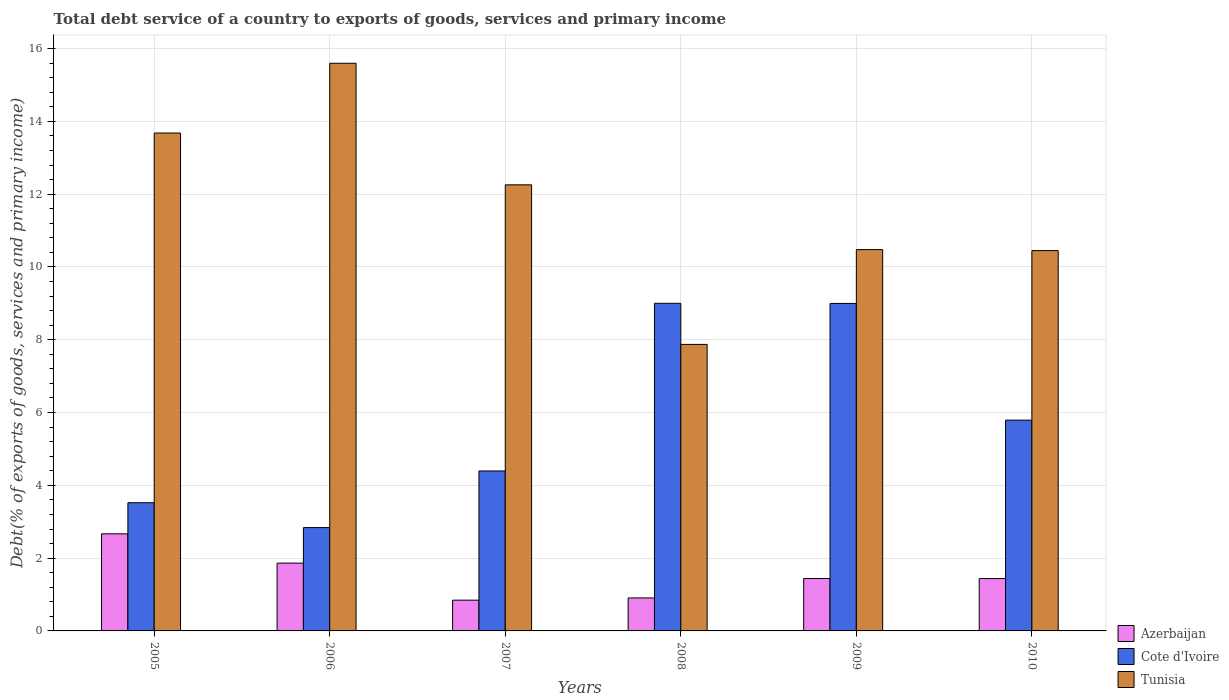How many different coloured bars are there?
Your answer should be compact. 3. Are the number of bars per tick equal to the number of legend labels?
Make the answer very short. Yes. How many bars are there on the 5th tick from the left?
Provide a succinct answer. 3. How many bars are there on the 2nd tick from the right?
Make the answer very short. 3. In how many cases, is the number of bars for a given year not equal to the number of legend labels?
Your answer should be very brief. 0. What is the total debt service in Azerbaijan in 2009?
Keep it short and to the point. 1.44. Across all years, what is the maximum total debt service in Azerbaijan?
Keep it short and to the point. 2.67. Across all years, what is the minimum total debt service in Cote d'Ivoire?
Offer a terse response. 2.84. In which year was the total debt service in Tunisia maximum?
Offer a very short reply. 2006. In which year was the total debt service in Azerbaijan minimum?
Your answer should be very brief. 2007. What is the total total debt service in Tunisia in the graph?
Provide a succinct answer. 70.33. What is the difference between the total debt service in Cote d'Ivoire in 2006 and that in 2009?
Provide a succinct answer. -6.16. What is the difference between the total debt service in Azerbaijan in 2005 and the total debt service in Tunisia in 2006?
Offer a terse response. -12.93. What is the average total debt service in Tunisia per year?
Your response must be concise. 11.72. In the year 2006, what is the difference between the total debt service in Azerbaijan and total debt service in Cote d'Ivoire?
Ensure brevity in your answer.  -0.98. What is the ratio of the total debt service in Azerbaijan in 2006 to that in 2008?
Provide a short and direct response. 2.06. Is the difference between the total debt service in Azerbaijan in 2006 and 2009 greater than the difference between the total debt service in Cote d'Ivoire in 2006 and 2009?
Your answer should be compact. Yes. What is the difference between the highest and the second highest total debt service in Azerbaijan?
Your answer should be very brief. 0.8. What is the difference between the highest and the lowest total debt service in Tunisia?
Ensure brevity in your answer.  7.72. Is the sum of the total debt service in Azerbaijan in 2005 and 2010 greater than the maximum total debt service in Tunisia across all years?
Provide a short and direct response. No. What does the 1st bar from the left in 2005 represents?
Make the answer very short. Azerbaijan. What does the 3rd bar from the right in 2008 represents?
Provide a succinct answer. Azerbaijan. How many bars are there?
Provide a succinct answer. 18. What is the difference between two consecutive major ticks on the Y-axis?
Give a very brief answer. 2. Does the graph contain grids?
Ensure brevity in your answer.  Yes. Where does the legend appear in the graph?
Keep it short and to the point. Bottom right. How many legend labels are there?
Offer a very short reply. 3. What is the title of the graph?
Offer a terse response. Total debt service of a country to exports of goods, services and primary income. Does "Bolivia" appear as one of the legend labels in the graph?
Offer a very short reply. No. What is the label or title of the Y-axis?
Make the answer very short. Debt(% of exports of goods, services and primary income). What is the Debt(% of exports of goods, services and primary income) of Azerbaijan in 2005?
Offer a terse response. 2.67. What is the Debt(% of exports of goods, services and primary income) in Cote d'Ivoire in 2005?
Ensure brevity in your answer.  3.52. What is the Debt(% of exports of goods, services and primary income) in Tunisia in 2005?
Your answer should be very brief. 13.68. What is the Debt(% of exports of goods, services and primary income) in Azerbaijan in 2006?
Your response must be concise. 1.86. What is the Debt(% of exports of goods, services and primary income) in Cote d'Ivoire in 2006?
Provide a succinct answer. 2.84. What is the Debt(% of exports of goods, services and primary income) of Tunisia in 2006?
Make the answer very short. 15.6. What is the Debt(% of exports of goods, services and primary income) in Azerbaijan in 2007?
Make the answer very short. 0.85. What is the Debt(% of exports of goods, services and primary income) in Cote d'Ivoire in 2007?
Provide a short and direct response. 4.39. What is the Debt(% of exports of goods, services and primary income) of Tunisia in 2007?
Ensure brevity in your answer.  12.26. What is the Debt(% of exports of goods, services and primary income) in Azerbaijan in 2008?
Give a very brief answer. 0.91. What is the Debt(% of exports of goods, services and primary income) in Cote d'Ivoire in 2008?
Provide a short and direct response. 9. What is the Debt(% of exports of goods, services and primary income) of Tunisia in 2008?
Your answer should be compact. 7.87. What is the Debt(% of exports of goods, services and primary income) of Azerbaijan in 2009?
Your response must be concise. 1.44. What is the Debt(% of exports of goods, services and primary income) of Cote d'Ivoire in 2009?
Give a very brief answer. 9. What is the Debt(% of exports of goods, services and primary income) in Tunisia in 2009?
Give a very brief answer. 10.48. What is the Debt(% of exports of goods, services and primary income) of Azerbaijan in 2010?
Offer a very short reply. 1.44. What is the Debt(% of exports of goods, services and primary income) of Cote d'Ivoire in 2010?
Provide a succinct answer. 5.79. What is the Debt(% of exports of goods, services and primary income) in Tunisia in 2010?
Offer a very short reply. 10.45. Across all years, what is the maximum Debt(% of exports of goods, services and primary income) in Azerbaijan?
Keep it short and to the point. 2.67. Across all years, what is the maximum Debt(% of exports of goods, services and primary income) in Cote d'Ivoire?
Keep it short and to the point. 9. Across all years, what is the maximum Debt(% of exports of goods, services and primary income) in Tunisia?
Offer a terse response. 15.6. Across all years, what is the minimum Debt(% of exports of goods, services and primary income) of Azerbaijan?
Make the answer very short. 0.85. Across all years, what is the minimum Debt(% of exports of goods, services and primary income) in Cote d'Ivoire?
Offer a terse response. 2.84. Across all years, what is the minimum Debt(% of exports of goods, services and primary income) in Tunisia?
Provide a short and direct response. 7.87. What is the total Debt(% of exports of goods, services and primary income) of Azerbaijan in the graph?
Offer a very short reply. 9.16. What is the total Debt(% of exports of goods, services and primary income) in Cote d'Ivoire in the graph?
Keep it short and to the point. 34.55. What is the total Debt(% of exports of goods, services and primary income) of Tunisia in the graph?
Offer a terse response. 70.33. What is the difference between the Debt(% of exports of goods, services and primary income) in Azerbaijan in 2005 and that in 2006?
Ensure brevity in your answer.  0.8. What is the difference between the Debt(% of exports of goods, services and primary income) of Cote d'Ivoire in 2005 and that in 2006?
Provide a succinct answer. 0.68. What is the difference between the Debt(% of exports of goods, services and primary income) in Tunisia in 2005 and that in 2006?
Provide a succinct answer. -1.92. What is the difference between the Debt(% of exports of goods, services and primary income) of Azerbaijan in 2005 and that in 2007?
Make the answer very short. 1.82. What is the difference between the Debt(% of exports of goods, services and primary income) in Cote d'Ivoire in 2005 and that in 2007?
Ensure brevity in your answer.  -0.87. What is the difference between the Debt(% of exports of goods, services and primary income) in Tunisia in 2005 and that in 2007?
Your answer should be compact. 1.42. What is the difference between the Debt(% of exports of goods, services and primary income) of Azerbaijan in 2005 and that in 2008?
Provide a succinct answer. 1.76. What is the difference between the Debt(% of exports of goods, services and primary income) of Cote d'Ivoire in 2005 and that in 2008?
Your answer should be very brief. -5.48. What is the difference between the Debt(% of exports of goods, services and primary income) of Tunisia in 2005 and that in 2008?
Your response must be concise. 5.81. What is the difference between the Debt(% of exports of goods, services and primary income) in Azerbaijan in 2005 and that in 2009?
Offer a terse response. 1.23. What is the difference between the Debt(% of exports of goods, services and primary income) of Cote d'Ivoire in 2005 and that in 2009?
Offer a very short reply. -5.47. What is the difference between the Debt(% of exports of goods, services and primary income) of Tunisia in 2005 and that in 2009?
Your answer should be very brief. 3.2. What is the difference between the Debt(% of exports of goods, services and primary income) in Azerbaijan in 2005 and that in 2010?
Make the answer very short. 1.23. What is the difference between the Debt(% of exports of goods, services and primary income) in Cote d'Ivoire in 2005 and that in 2010?
Your response must be concise. -2.27. What is the difference between the Debt(% of exports of goods, services and primary income) of Tunisia in 2005 and that in 2010?
Provide a succinct answer. 3.23. What is the difference between the Debt(% of exports of goods, services and primary income) in Azerbaijan in 2006 and that in 2007?
Provide a succinct answer. 1.02. What is the difference between the Debt(% of exports of goods, services and primary income) of Cote d'Ivoire in 2006 and that in 2007?
Make the answer very short. -1.56. What is the difference between the Debt(% of exports of goods, services and primary income) of Tunisia in 2006 and that in 2007?
Offer a terse response. 3.34. What is the difference between the Debt(% of exports of goods, services and primary income) in Azerbaijan in 2006 and that in 2008?
Provide a succinct answer. 0.96. What is the difference between the Debt(% of exports of goods, services and primary income) of Cote d'Ivoire in 2006 and that in 2008?
Offer a terse response. -6.16. What is the difference between the Debt(% of exports of goods, services and primary income) of Tunisia in 2006 and that in 2008?
Offer a terse response. 7.72. What is the difference between the Debt(% of exports of goods, services and primary income) in Azerbaijan in 2006 and that in 2009?
Your response must be concise. 0.42. What is the difference between the Debt(% of exports of goods, services and primary income) in Cote d'Ivoire in 2006 and that in 2009?
Ensure brevity in your answer.  -6.16. What is the difference between the Debt(% of exports of goods, services and primary income) in Tunisia in 2006 and that in 2009?
Your response must be concise. 5.12. What is the difference between the Debt(% of exports of goods, services and primary income) of Azerbaijan in 2006 and that in 2010?
Your response must be concise. 0.42. What is the difference between the Debt(% of exports of goods, services and primary income) of Cote d'Ivoire in 2006 and that in 2010?
Give a very brief answer. -2.95. What is the difference between the Debt(% of exports of goods, services and primary income) of Tunisia in 2006 and that in 2010?
Provide a short and direct response. 5.15. What is the difference between the Debt(% of exports of goods, services and primary income) in Azerbaijan in 2007 and that in 2008?
Provide a short and direct response. -0.06. What is the difference between the Debt(% of exports of goods, services and primary income) in Cote d'Ivoire in 2007 and that in 2008?
Give a very brief answer. -4.61. What is the difference between the Debt(% of exports of goods, services and primary income) of Tunisia in 2007 and that in 2008?
Provide a succinct answer. 4.38. What is the difference between the Debt(% of exports of goods, services and primary income) of Azerbaijan in 2007 and that in 2009?
Give a very brief answer. -0.59. What is the difference between the Debt(% of exports of goods, services and primary income) in Cote d'Ivoire in 2007 and that in 2009?
Your response must be concise. -4.6. What is the difference between the Debt(% of exports of goods, services and primary income) of Tunisia in 2007 and that in 2009?
Keep it short and to the point. 1.78. What is the difference between the Debt(% of exports of goods, services and primary income) in Azerbaijan in 2007 and that in 2010?
Make the answer very short. -0.59. What is the difference between the Debt(% of exports of goods, services and primary income) in Cote d'Ivoire in 2007 and that in 2010?
Offer a very short reply. -1.4. What is the difference between the Debt(% of exports of goods, services and primary income) in Tunisia in 2007 and that in 2010?
Your response must be concise. 1.81. What is the difference between the Debt(% of exports of goods, services and primary income) of Azerbaijan in 2008 and that in 2009?
Make the answer very short. -0.53. What is the difference between the Debt(% of exports of goods, services and primary income) in Cote d'Ivoire in 2008 and that in 2009?
Offer a terse response. 0. What is the difference between the Debt(% of exports of goods, services and primary income) of Tunisia in 2008 and that in 2009?
Make the answer very short. -2.6. What is the difference between the Debt(% of exports of goods, services and primary income) in Azerbaijan in 2008 and that in 2010?
Offer a terse response. -0.53. What is the difference between the Debt(% of exports of goods, services and primary income) in Cote d'Ivoire in 2008 and that in 2010?
Ensure brevity in your answer.  3.21. What is the difference between the Debt(% of exports of goods, services and primary income) in Tunisia in 2008 and that in 2010?
Provide a succinct answer. -2.58. What is the difference between the Debt(% of exports of goods, services and primary income) in Azerbaijan in 2009 and that in 2010?
Make the answer very short. 0. What is the difference between the Debt(% of exports of goods, services and primary income) of Cote d'Ivoire in 2009 and that in 2010?
Keep it short and to the point. 3.21. What is the difference between the Debt(% of exports of goods, services and primary income) in Tunisia in 2009 and that in 2010?
Provide a short and direct response. 0.03. What is the difference between the Debt(% of exports of goods, services and primary income) of Azerbaijan in 2005 and the Debt(% of exports of goods, services and primary income) of Cote d'Ivoire in 2006?
Provide a short and direct response. -0.17. What is the difference between the Debt(% of exports of goods, services and primary income) in Azerbaijan in 2005 and the Debt(% of exports of goods, services and primary income) in Tunisia in 2006?
Give a very brief answer. -12.93. What is the difference between the Debt(% of exports of goods, services and primary income) in Cote d'Ivoire in 2005 and the Debt(% of exports of goods, services and primary income) in Tunisia in 2006?
Offer a terse response. -12.07. What is the difference between the Debt(% of exports of goods, services and primary income) of Azerbaijan in 2005 and the Debt(% of exports of goods, services and primary income) of Cote d'Ivoire in 2007?
Offer a terse response. -1.73. What is the difference between the Debt(% of exports of goods, services and primary income) of Azerbaijan in 2005 and the Debt(% of exports of goods, services and primary income) of Tunisia in 2007?
Keep it short and to the point. -9.59. What is the difference between the Debt(% of exports of goods, services and primary income) in Cote d'Ivoire in 2005 and the Debt(% of exports of goods, services and primary income) in Tunisia in 2007?
Your answer should be very brief. -8.73. What is the difference between the Debt(% of exports of goods, services and primary income) in Azerbaijan in 2005 and the Debt(% of exports of goods, services and primary income) in Cote d'Ivoire in 2008?
Offer a terse response. -6.33. What is the difference between the Debt(% of exports of goods, services and primary income) of Azerbaijan in 2005 and the Debt(% of exports of goods, services and primary income) of Tunisia in 2008?
Offer a terse response. -5.21. What is the difference between the Debt(% of exports of goods, services and primary income) in Cote d'Ivoire in 2005 and the Debt(% of exports of goods, services and primary income) in Tunisia in 2008?
Give a very brief answer. -4.35. What is the difference between the Debt(% of exports of goods, services and primary income) in Azerbaijan in 2005 and the Debt(% of exports of goods, services and primary income) in Cote d'Ivoire in 2009?
Offer a very short reply. -6.33. What is the difference between the Debt(% of exports of goods, services and primary income) in Azerbaijan in 2005 and the Debt(% of exports of goods, services and primary income) in Tunisia in 2009?
Your response must be concise. -7.81. What is the difference between the Debt(% of exports of goods, services and primary income) of Cote d'Ivoire in 2005 and the Debt(% of exports of goods, services and primary income) of Tunisia in 2009?
Provide a short and direct response. -6.95. What is the difference between the Debt(% of exports of goods, services and primary income) of Azerbaijan in 2005 and the Debt(% of exports of goods, services and primary income) of Cote d'Ivoire in 2010?
Give a very brief answer. -3.12. What is the difference between the Debt(% of exports of goods, services and primary income) in Azerbaijan in 2005 and the Debt(% of exports of goods, services and primary income) in Tunisia in 2010?
Provide a succinct answer. -7.78. What is the difference between the Debt(% of exports of goods, services and primary income) of Cote d'Ivoire in 2005 and the Debt(% of exports of goods, services and primary income) of Tunisia in 2010?
Your answer should be compact. -6.93. What is the difference between the Debt(% of exports of goods, services and primary income) in Azerbaijan in 2006 and the Debt(% of exports of goods, services and primary income) in Cote d'Ivoire in 2007?
Your answer should be very brief. -2.53. What is the difference between the Debt(% of exports of goods, services and primary income) in Azerbaijan in 2006 and the Debt(% of exports of goods, services and primary income) in Tunisia in 2007?
Offer a terse response. -10.39. What is the difference between the Debt(% of exports of goods, services and primary income) in Cote d'Ivoire in 2006 and the Debt(% of exports of goods, services and primary income) in Tunisia in 2007?
Provide a succinct answer. -9.42. What is the difference between the Debt(% of exports of goods, services and primary income) in Azerbaijan in 2006 and the Debt(% of exports of goods, services and primary income) in Cote d'Ivoire in 2008?
Your answer should be very brief. -7.14. What is the difference between the Debt(% of exports of goods, services and primary income) in Azerbaijan in 2006 and the Debt(% of exports of goods, services and primary income) in Tunisia in 2008?
Offer a very short reply. -6.01. What is the difference between the Debt(% of exports of goods, services and primary income) of Cote d'Ivoire in 2006 and the Debt(% of exports of goods, services and primary income) of Tunisia in 2008?
Ensure brevity in your answer.  -5.03. What is the difference between the Debt(% of exports of goods, services and primary income) in Azerbaijan in 2006 and the Debt(% of exports of goods, services and primary income) in Cote d'Ivoire in 2009?
Your response must be concise. -7.13. What is the difference between the Debt(% of exports of goods, services and primary income) in Azerbaijan in 2006 and the Debt(% of exports of goods, services and primary income) in Tunisia in 2009?
Offer a terse response. -8.61. What is the difference between the Debt(% of exports of goods, services and primary income) of Cote d'Ivoire in 2006 and the Debt(% of exports of goods, services and primary income) of Tunisia in 2009?
Keep it short and to the point. -7.64. What is the difference between the Debt(% of exports of goods, services and primary income) of Azerbaijan in 2006 and the Debt(% of exports of goods, services and primary income) of Cote d'Ivoire in 2010?
Provide a succinct answer. -3.93. What is the difference between the Debt(% of exports of goods, services and primary income) of Azerbaijan in 2006 and the Debt(% of exports of goods, services and primary income) of Tunisia in 2010?
Make the answer very short. -8.59. What is the difference between the Debt(% of exports of goods, services and primary income) of Cote d'Ivoire in 2006 and the Debt(% of exports of goods, services and primary income) of Tunisia in 2010?
Your answer should be compact. -7.61. What is the difference between the Debt(% of exports of goods, services and primary income) of Azerbaijan in 2007 and the Debt(% of exports of goods, services and primary income) of Cote d'Ivoire in 2008?
Your answer should be very brief. -8.16. What is the difference between the Debt(% of exports of goods, services and primary income) of Azerbaijan in 2007 and the Debt(% of exports of goods, services and primary income) of Tunisia in 2008?
Your answer should be very brief. -7.03. What is the difference between the Debt(% of exports of goods, services and primary income) of Cote d'Ivoire in 2007 and the Debt(% of exports of goods, services and primary income) of Tunisia in 2008?
Offer a very short reply. -3.48. What is the difference between the Debt(% of exports of goods, services and primary income) in Azerbaijan in 2007 and the Debt(% of exports of goods, services and primary income) in Cote d'Ivoire in 2009?
Provide a succinct answer. -8.15. What is the difference between the Debt(% of exports of goods, services and primary income) of Azerbaijan in 2007 and the Debt(% of exports of goods, services and primary income) of Tunisia in 2009?
Your answer should be compact. -9.63. What is the difference between the Debt(% of exports of goods, services and primary income) in Cote d'Ivoire in 2007 and the Debt(% of exports of goods, services and primary income) in Tunisia in 2009?
Your answer should be very brief. -6.08. What is the difference between the Debt(% of exports of goods, services and primary income) of Azerbaijan in 2007 and the Debt(% of exports of goods, services and primary income) of Cote d'Ivoire in 2010?
Your answer should be very brief. -4.95. What is the difference between the Debt(% of exports of goods, services and primary income) in Azerbaijan in 2007 and the Debt(% of exports of goods, services and primary income) in Tunisia in 2010?
Provide a succinct answer. -9.6. What is the difference between the Debt(% of exports of goods, services and primary income) in Cote d'Ivoire in 2007 and the Debt(% of exports of goods, services and primary income) in Tunisia in 2010?
Keep it short and to the point. -6.05. What is the difference between the Debt(% of exports of goods, services and primary income) of Azerbaijan in 2008 and the Debt(% of exports of goods, services and primary income) of Cote d'Ivoire in 2009?
Provide a short and direct response. -8.09. What is the difference between the Debt(% of exports of goods, services and primary income) of Azerbaijan in 2008 and the Debt(% of exports of goods, services and primary income) of Tunisia in 2009?
Offer a very short reply. -9.57. What is the difference between the Debt(% of exports of goods, services and primary income) in Cote d'Ivoire in 2008 and the Debt(% of exports of goods, services and primary income) in Tunisia in 2009?
Your answer should be very brief. -1.48. What is the difference between the Debt(% of exports of goods, services and primary income) in Azerbaijan in 2008 and the Debt(% of exports of goods, services and primary income) in Cote d'Ivoire in 2010?
Ensure brevity in your answer.  -4.89. What is the difference between the Debt(% of exports of goods, services and primary income) of Azerbaijan in 2008 and the Debt(% of exports of goods, services and primary income) of Tunisia in 2010?
Your response must be concise. -9.54. What is the difference between the Debt(% of exports of goods, services and primary income) in Cote d'Ivoire in 2008 and the Debt(% of exports of goods, services and primary income) in Tunisia in 2010?
Your response must be concise. -1.45. What is the difference between the Debt(% of exports of goods, services and primary income) of Azerbaijan in 2009 and the Debt(% of exports of goods, services and primary income) of Cote d'Ivoire in 2010?
Your answer should be compact. -4.35. What is the difference between the Debt(% of exports of goods, services and primary income) of Azerbaijan in 2009 and the Debt(% of exports of goods, services and primary income) of Tunisia in 2010?
Your answer should be very brief. -9.01. What is the difference between the Debt(% of exports of goods, services and primary income) of Cote d'Ivoire in 2009 and the Debt(% of exports of goods, services and primary income) of Tunisia in 2010?
Provide a succinct answer. -1.45. What is the average Debt(% of exports of goods, services and primary income) of Azerbaijan per year?
Keep it short and to the point. 1.53. What is the average Debt(% of exports of goods, services and primary income) of Cote d'Ivoire per year?
Your answer should be compact. 5.76. What is the average Debt(% of exports of goods, services and primary income) in Tunisia per year?
Provide a short and direct response. 11.72. In the year 2005, what is the difference between the Debt(% of exports of goods, services and primary income) in Azerbaijan and Debt(% of exports of goods, services and primary income) in Cote d'Ivoire?
Offer a terse response. -0.86. In the year 2005, what is the difference between the Debt(% of exports of goods, services and primary income) in Azerbaijan and Debt(% of exports of goods, services and primary income) in Tunisia?
Provide a short and direct response. -11.01. In the year 2005, what is the difference between the Debt(% of exports of goods, services and primary income) in Cote d'Ivoire and Debt(% of exports of goods, services and primary income) in Tunisia?
Make the answer very short. -10.16. In the year 2006, what is the difference between the Debt(% of exports of goods, services and primary income) of Azerbaijan and Debt(% of exports of goods, services and primary income) of Cote d'Ivoire?
Provide a short and direct response. -0.98. In the year 2006, what is the difference between the Debt(% of exports of goods, services and primary income) of Azerbaijan and Debt(% of exports of goods, services and primary income) of Tunisia?
Your answer should be compact. -13.73. In the year 2006, what is the difference between the Debt(% of exports of goods, services and primary income) in Cote d'Ivoire and Debt(% of exports of goods, services and primary income) in Tunisia?
Keep it short and to the point. -12.76. In the year 2007, what is the difference between the Debt(% of exports of goods, services and primary income) of Azerbaijan and Debt(% of exports of goods, services and primary income) of Cote d'Ivoire?
Make the answer very short. -3.55. In the year 2007, what is the difference between the Debt(% of exports of goods, services and primary income) of Azerbaijan and Debt(% of exports of goods, services and primary income) of Tunisia?
Offer a very short reply. -11.41. In the year 2007, what is the difference between the Debt(% of exports of goods, services and primary income) of Cote d'Ivoire and Debt(% of exports of goods, services and primary income) of Tunisia?
Your response must be concise. -7.86. In the year 2008, what is the difference between the Debt(% of exports of goods, services and primary income) in Azerbaijan and Debt(% of exports of goods, services and primary income) in Cote d'Ivoire?
Your answer should be compact. -8.1. In the year 2008, what is the difference between the Debt(% of exports of goods, services and primary income) in Azerbaijan and Debt(% of exports of goods, services and primary income) in Tunisia?
Your response must be concise. -6.97. In the year 2008, what is the difference between the Debt(% of exports of goods, services and primary income) in Cote d'Ivoire and Debt(% of exports of goods, services and primary income) in Tunisia?
Make the answer very short. 1.13. In the year 2009, what is the difference between the Debt(% of exports of goods, services and primary income) in Azerbaijan and Debt(% of exports of goods, services and primary income) in Cote d'Ivoire?
Offer a very short reply. -7.56. In the year 2009, what is the difference between the Debt(% of exports of goods, services and primary income) of Azerbaijan and Debt(% of exports of goods, services and primary income) of Tunisia?
Provide a short and direct response. -9.04. In the year 2009, what is the difference between the Debt(% of exports of goods, services and primary income) of Cote d'Ivoire and Debt(% of exports of goods, services and primary income) of Tunisia?
Your answer should be very brief. -1.48. In the year 2010, what is the difference between the Debt(% of exports of goods, services and primary income) of Azerbaijan and Debt(% of exports of goods, services and primary income) of Cote d'Ivoire?
Your answer should be compact. -4.35. In the year 2010, what is the difference between the Debt(% of exports of goods, services and primary income) of Azerbaijan and Debt(% of exports of goods, services and primary income) of Tunisia?
Your answer should be compact. -9.01. In the year 2010, what is the difference between the Debt(% of exports of goods, services and primary income) in Cote d'Ivoire and Debt(% of exports of goods, services and primary income) in Tunisia?
Ensure brevity in your answer.  -4.66. What is the ratio of the Debt(% of exports of goods, services and primary income) of Azerbaijan in 2005 to that in 2006?
Provide a succinct answer. 1.43. What is the ratio of the Debt(% of exports of goods, services and primary income) in Cote d'Ivoire in 2005 to that in 2006?
Give a very brief answer. 1.24. What is the ratio of the Debt(% of exports of goods, services and primary income) of Tunisia in 2005 to that in 2006?
Provide a short and direct response. 0.88. What is the ratio of the Debt(% of exports of goods, services and primary income) of Azerbaijan in 2005 to that in 2007?
Make the answer very short. 3.16. What is the ratio of the Debt(% of exports of goods, services and primary income) of Cote d'Ivoire in 2005 to that in 2007?
Ensure brevity in your answer.  0.8. What is the ratio of the Debt(% of exports of goods, services and primary income) of Tunisia in 2005 to that in 2007?
Offer a terse response. 1.12. What is the ratio of the Debt(% of exports of goods, services and primary income) in Azerbaijan in 2005 to that in 2008?
Your response must be concise. 2.94. What is the ratio of the Debt(% of exports of goods, services and primary income) in Cote d'Ivoire in 2005 to that in 2008?
Make the answer very short. 0.39. What is the ratio of the Debt(% of exports of goods, services and primary income) of Tunisia in 2005 to that in 2008?
Offer a terse response. 1.74. What is the ratio of the Debt(% of exports of goods, services and primary income) in Azerbaijan in 2005 to that in 2009?
Offer a terse response. 1.85. What is the ratio of the Debt(% of exports of goods, services and primary income) in Cote d'Ivoire in 2005 to that in 2009?
Provide a succinct answer. 0.39. What is the ratio of the Debt(% of exports of goods, services and primary income) of Tunisia in 2005 to that in 2009?
Ensure brevity in your answer.  1.31. What is the ratio of the Debt(% of exports of goods, services and primary income) of Azerbaijan in 2005 to that in 2010?
Your response must be concise. 1.85. What is the ratio of the Debt(% of exports of goods, services and primary income) in Cote d'Ivoire in 2005 to that in 2010?
Offer a terse response. 0.61. What is the ratio of the Debt(% of exports of goods, services and primary income) in Tunisia in 2005 to that in 2010?
Your answer should be very brief. 1.31. What is the ratio of the Debt(% of exports of goods, services and primary income) in Azerbaijan in 2006 to that in 2007?
Keep it short and to the point. 2.2. What is the ratio of the Debt(% of exports of goods, services and primary income) in Cote d'Ivoire in 2006 to that in 2007?
Keep it short and to the point. 0.65. What is the ratio of the Debt(% of exports of goods, services and primary income) of Tunisia in 2006 to that in 2007?
Keep it short and to the point. 1.27. What is the ratio of the Debt(% of exports of goods, services and primary income) in Azerbaijan in 2006 to that in 2008?
Provide a short and direct response. 2.06. What is the ratio of the Debt(% of exports of goods, services and primary income) in Cote d'Ivoire in 2006 to that in 2008?
Make the answer very short. 0.32. What is the ratio of the Debt(% of exports of goods, services and primary income) of Tunisia in 2006 to that in 2008?
Your answer should be compact. 1.98. What is the ratio of the Debt(% of exports of goods, services and primary income) of Azerbaijan in 2006 to that in 2009?
Provide a short and direct response. 1.29. What is the ratio of the Debt(% of exports of goods, services and primary income) of Cote d'Ivoire in 2006 to that in 2009?
Provide a short and direct response. 0.32. What is the ratio of the Debt(% of exports of goods, services and primary income) of Tunisia in 2006 to that in 2009?
Provide a short and direct response. 1.49. What is the ratio of the Debt(% of exports of goods, services and primary income) of Azerbaijan in 2006 to that in 2010?
Give a very brief answer. 1.3. What is the ratio of the Debt(% of exports of goods, services and primary income) of Cote d'Ivoire in 2006 to that in 2010?
Make the answer very short. 0.49. What is the ratio of the Debt(% of exports of goods, services and primary income) in Tunisia in 2006 to that in 2010?
Your answer should be compact. 1.49. What is the ratio of the Debt(% of exports of goods, services and primary income) of Azerbaijan in 2007 to that in 2008?
Offer a very short reply. 0.93. What is the ratio of the Debt(% of exports of goods, services and primary income) in Cote d'Ivoire in 2007 to that in 2008?
Keep it short and to the point. 0.49. What is the ratio of the Debt(% of exports of goods, services and primary income) of Tunisia in 2007 to that in 2008?
Your answer should be very brief. 1.56. What is the ratio of the Debt(% of exports of goods, services and primary income) in Azerbaijan in 2007 to that in 2009?
Ensure brevity in your answer.  0.59. What is the ratio of the Debt(% of exports of goods, services and primary income) of Cote d'Ivoire in 2007 to that in 2009?
Keep it short and to the point. 0.49. What is the ratio of the Debt(% of exports of goods, services and primary income) of Tunisia in 2007 to that in 2009?
Your answer should be compact. 1.17. What is the ratio of the Debt(% of exports of goods, services and primary income) of Azerbaijan in 2007 to that in 2010?
Provide a short and direct response. 0.59. What is the ratio of the Debt(% of exports of goods, services and primary income) of Cote d'Ivoire in 2007 to that in 2010?
Provide a succinct answer. 0.76. What is the ratio of the Debt(% of exports of goods, services and primary income) in Tunisia in 2007 to that in 2010?
Ensure brevity in your answer.  1.17. What is the ratio of the Debt(% of exports of goods, services and primary income) of Azerbaijan in 2008 to that in 2009?
Ensure brevity in your answer.  0.63. What is the ratio of the Debt(% of exports of goods, services and primary income) of Cote d'Ivoire in 2008 to that in 2009?
Offer a very short reply. 1. What is the ratio of the Debt(% of exports of goods, services and primary income) in Tunisia in 2008 to that in 2009?
Provide a succinct answer. 0.75. What is the ratio of the Debt(% of exports of goods, services and primary income) of Azerbaijan in 2008 to that in 2010?
Keep it short and to the point. 0.63. What is the ratio of the Debt(% of exports of goods, services and primary income) in Cote d'Ivoire in 2008 to that in 2010?
Offer a very short reply. 1.55. What is the ratio of the Debt(% of exports of goods, services and primary income) of Tunisia in 2008 to that in 2010?
Offer a very short reply. 0.75. What is the ratio of the Debt(% of exports of goods, services and primary income) in Azerbaijan in 2009 to that in 2010?
Offer a terse response. 1. What is the ratio of the Debt(% of exports of goods, services and primary income) in Cote d'Ivoire in 2009 to that in 2010?
Provide a succinct answer. 1.55. What is the ratio of the Debt(% of exports of goods, services and primary income) of Tunisia in 2009 to that in 2010?
Your answer should be very brief. 1. What is the difference between the highest and the second highest Debt(% of exports of goods, services and primary income) in Azerbaijan?
Your answer should be compact. 0.8. What is the difference between the highest and the second highest Debt(% of exports of goods, services and primary income) of Cote d'Ivoire?
Your answer should be compact. 0. What is the difference between the highest and the second highest Debt(% of exports of goods, services and primary income) in Tunisia?
Provide a succinct answer. 1.92. What is the difference between the highest and the lowest Debt(% of exports of goods, services and primary income) in Azerbaijan?
Offer a terse response. 1.82. What is the difference between the highest and the lowest Debt(% of exports of goods, services and primary income) in Cote d'Ivoire?
Ensure brevity in your answer.  6.16. What is the difference between the highest and the lowest Debt(% of exports of goods, services and primary income) of Tunisia?
Ensure brevity in your answer.  7.72. 